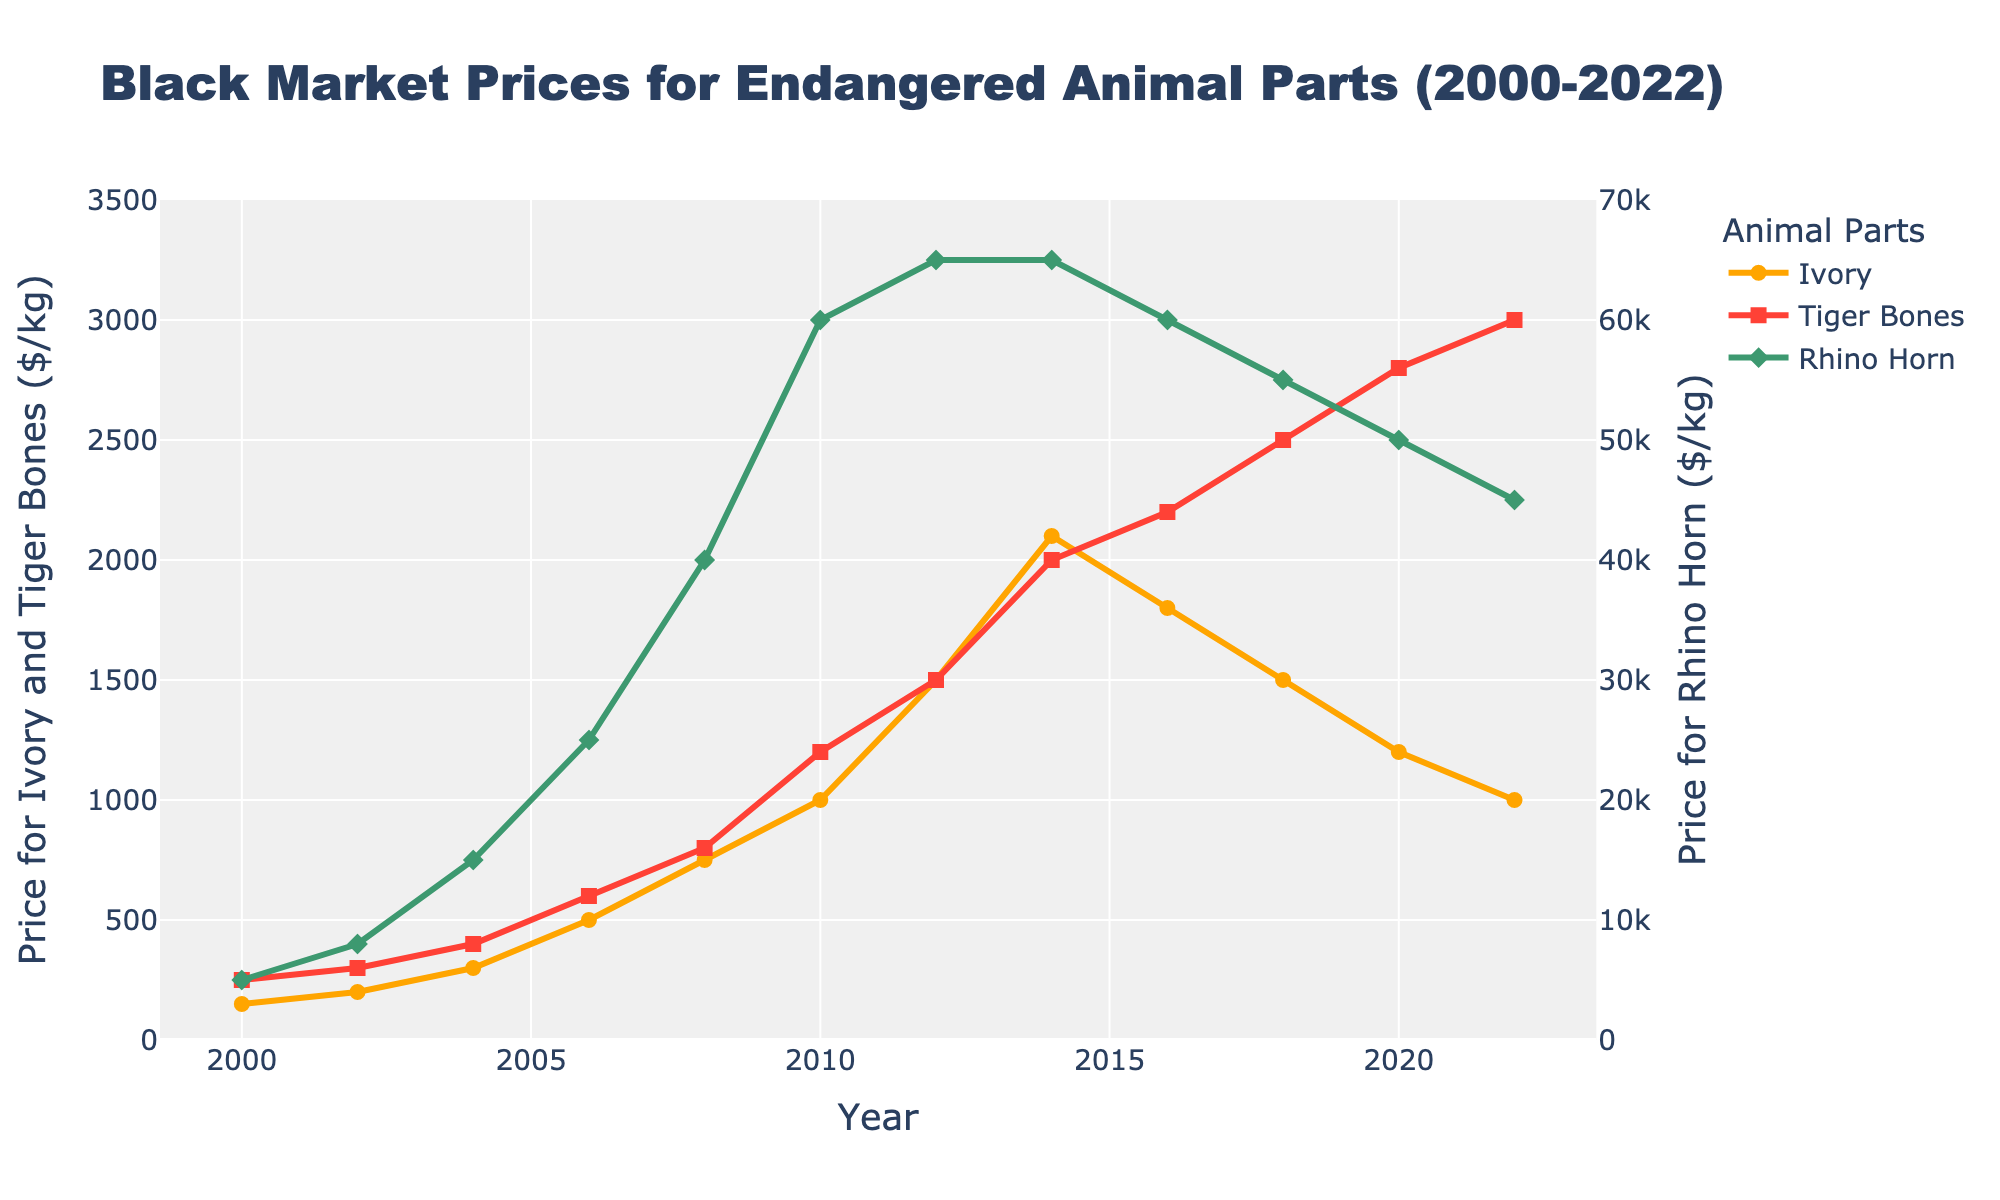What is the trend in ivory prices from 2000 to 2022? To determine the trend, observe the changes in ivory prices over time. From 2000 to 2014, prices generally increased, peaking at $2100/kg in 2014. Afterward, prices declined, reaching $1000/kg by 2022.
Answer: Prices increased until 2014, then decreased When did rhino horn prices reach their peak, and what was the price? To find the peak, look for the highest point in the rhino horn prices on the line chart. The peak occurred in 2012 and 2014, both at $65,000/kg.
Answer: 2012-2014, $65,000/kg How does the 2022 price of tiger bones compare to its price in 2000? Compare the values of tiger bones' prices in the years 2000 and 2022 on the line chart. The price in 2000 was $250/kg, whereas in 2022, it was $3000/kg.
Answer: 2022 is higher than 2000 What is the difference between the highest and lowest prices of ivory throughout the years? Find the highest and lowest data points on the ivory price line. The highest price was $2100/kg in 2014, and the lowest was $150/kg in 2000. The difference is $2100 - $150 = $1950.
Answer: $1950 During which period did rhino horn prices decline the most? Analyze the periods of sharp declines in the rhino horn prices on the line chart. The most significant decline occurred between 2014 and 2022, from $65,000/kg to $45,000/kg.
Answer: 2014-2022 What is the average price of tiger bones from 2010 to 2022? Determine the prices of tiger bones in the years 2010, 2012, 2014, 2016, 2018, 2020, and 2022, and compute the average: (1200 + 1500 + 2000 + 2200 + 2500 + 2800 + 3000) / 7 = 2171.43.
Answer: $2171.43/kg Which animal part showed the most stable price trend over the years? Look for the line with the least fluctuations. The line representing tiger bones shows a relatively consistent upward trend compared to ivory and rhino horn.
Answer: Tiger bones In what year did the price of ivory first exceed $500/kg? Locate the point on the ivory price line where it first surpasses $500/kg, which happens in 2006.
Answer: 2006 How did the price of rhino horn in 2008 compare to the price of tiger bones in 2018? Compare the data points for rhino horn in 2008 ($40,000/kg) and tiger bones in 2018 ($2500/kg).
Answer: Rhino horn was much higher What is the price ratio of rhino horn to ivory in 2012? Calculate the ratio by dividing the price of rhino horn by the price of ivory in 2012: $65,000/kg ÷ $1500/kg = 43.33.
Answer: 43.33 